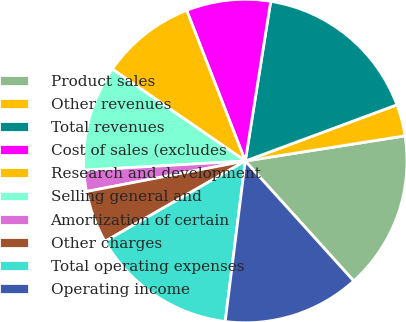Convert chart. <chart><loc_0><loc_0><loc_500><loc_500><pie_chart><fcel>Product sales<fcel>Other revenues<fcel>Total revenues<fcel>Cost of sales (excludes<fcel>Research and development<fcel>Selling general and<fcel>Amortization of certain<fcel>Other charges<fcel>Total operating expenses<fcel>Operating income<nl><fcel>15.79%<fcel>3.16%<fcel>16.84%<fcel>8.42%<fcel>9.47%<fcel>10.53%<fcel>2.11%<fcel>5.26%<fcel>14.74%<fcel>13.68%<nl></chart> 